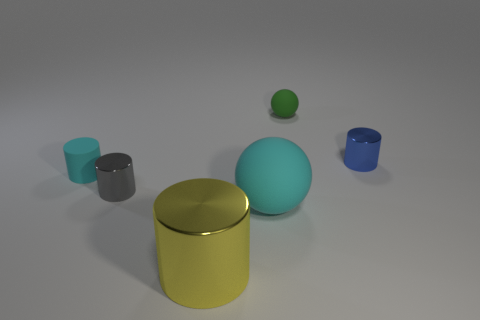How many metal objects are there?
Ensure brevity in your answer.  3. What number of objects are the same color as the rubber cylinder?
Provide a short and direct response. 1. There is a cyan thing that is to the right of the cyan rubber cylinder; does it have the same shape as the thing that is right of the green thing?
Ensure brevity in your answer.  No. What color is the ball that is in front of the small rubber thing on the right side of the ball that is in front of the blue cylinder?
Your answer should be compact. Cyan. There is a metallic thing that is to the left of the large yellow cylinder; what is its color?
Make the answer very short. Gray. What is the color of the rubber object that is the same size as the yellow shiny cylinder?
Offer a very short reply. Cyan. Do the gray cylinder and the yellow metal object have the same size?
Ensure brevity in your answer.  No. What number of blue metallic things are in front of the small rubber sphere?
Give a very brief answer. 1. How many objects are small cylinders that are on the right side of the big yellow metallic cylinder or small blue metal objects?
Provide a succinct answer. 1. Is the number of tiny gray objects that are behind the yellow cylinder greater than the number of tiny blue metal cylinders behind the blue shiny object?
Offer a terse response. Yes. 